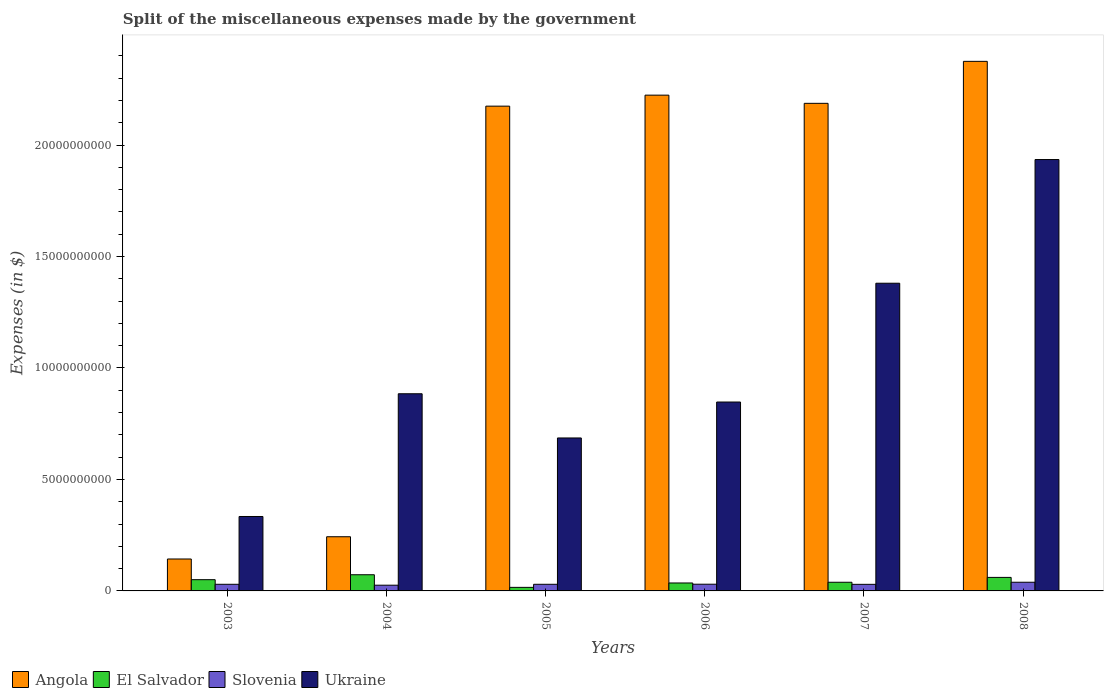How many different coloured bars are there?
Your answer should be very brief. 4. Are the number of bars per tick equal to the number of legend labels?
Offer a very short reply. Yes. How many bars are there on the 2nd tick from the left?
Make the answer very short. 4. How many bars are there on the 2nd tick from the right?
Offer a terse response. 4. What is the miscellaneous expenses made by the government in Angola in 2007?
Make the answer very short. 2.19e+1. Across all years, what is the maximum miscellaneous expenses made by the government in Ukraine?
Offer a very short reply. 1.93e+1. Across all years, what is the minimum miscellaneous expenses made by the government in Angola?
Your answer should be compact. 1.43e+09. In which year was the miscellaneous expenses made by the government in Angola minimum?
Ensure brevity in your answer.  2003. What is the total miscellaneous expenses made by the government in Slovenia in the graph?
Your answer should be compact. 1.84e+09. What is the difference between the miscellaneous expenses made by the government in Slovenia in 2003 and that in 2006?
Offer a very short reply. -2.95e+06. What is the difference between the miscellaneous expenses made by the government in Ukraine in 2006 and the miscellaneous expenses made by the government in Slovenia in 2004?
Provide a short and direct response. 8.22e+09. What is the average miscellaneous expenses made by the government in Ukraine per year?
Your response must be concise. 1.01e+1. In the year 2003, what is the difference between the miscellaneous expenses made by the government in Slovenia and miscellaneous expenses made by the government in El Salvador?
Offer a very short reply. -2.06e+08. In how many years, is the miscellaneous expenses made by the government in Ukraine greater than 17000000000 $?
Provide a short and direct response. 1. What is the ratio of the miscellaneous expenses made by the government in Ukraine in 2003 to that in 2007?
Offer a terse response. 0.24. What is the difference between the highest and the second highest miscellaneous expenses made by the government in Slovenia?
Your answer should be very brief. 8.84e+07. What is the difference between the highest and the lowest miscellaneous expenses made by the government in Ukraine?
Make the answer very short. 1.60e+1. What does the 3rd bar from the left in 2004 represents?
Your answer should be very brief. Slovenia. What does the 1st bar from the right in 2003 represents?
Offer a terse response. Ukraine. Are all the bars in the graph horizontal?
Offer a terse response. No. Does the graph contain grids?
Keep it short and to the point. No. Where does the legend appear in the graph?
Your answer should be compact. Bottom left. How many legend labels are there?
Provide a short and direct response. 4. How are the legend labels stacked?
Your answer should be very brief. Horizontal. What is the title of the graph?
Ensure brevity in your answer.  Split of the miscellaneous expenses made by the government. Does "Kosovo" appear as one of the legend labels in the graph?
Your answer should be compact. No. What is the label or title of the Y-axis?
Keep it short and to the point. Expenses (in $). What is the Expenses (in $) in Angola in 2003?
Provide a succinct answer. 1.43e+09. What is the Expenses (in $) in El Salvador in 2003?
Offer a terse response. 5.04e+08. What is the Expenses (in $) in Slovenia in 2003?
Provide a short and direct response. 2.98e+08. What is the Expenses (in $) in Ukraine in 2003?
Your response must be concise. 3.34e+09. What is the Expenses (in $) of Angola in 2004?
Offer a terse response. 2.43e+09. What is the Expenses (in $) of El Salvador in 2004?
Ensure brevity in your answer.  7.26e+08. What is the Expenses (in $) in Slovenia in 2004?
Your answer should be very brief. 2.57e+08. What is the Expenses (in $) of Ukraine in 2004?
Give a very brief answer. 8.84e+09. What is the Expenses (in $) in Angola in 2005?
Give a very brief answer. 2.17e+1. What is the Expenses (in $) in El Salvador in 2005?
Give a very brief answer. 1.60e+08. What is the Expenses (in $) of Slovenia in 2005?
Make the answer very short. 2.97e+08. What is the Expenses (in $) in Ukraine in 2005?
Keep it short and to the point. 6.86e+09. What is the Expenses (in $) in Angola in 2006?
Keep it short and to the point. 2.22e+1. What is the Expenses (in $) of El Salvador in 2006?
Give a very brief answer. 3.57e+08. What is the Expenses (in $) in Slovenia in 2006?
Provide a succinct answer. 3.01e+08. What is the Expenses (in $) in Ukraine in 2006?
Offer a very short reply. 8.47e+09. What is the Expenses (in $) of Angola in 2007?
Offer a terse response. 2.19e+1. What is the Expenses (in $) in El Salvador in 2007?
Provide a short and direct response. 3.88e+08. What is the Expenses (in $) of Slovenia in 2007?
Offer a terse response. 2.95e+08. What is the Expenses (in $) in Ukraine in 2007?
Provide a succinct answer. 1.38e+1. What is the Expenses (in $) of Angola in 2008?
Make the answer very short. 2.38e+1. What is the Expenses (in $) in El Salvador in 2008?
Give a very brief answer. 6.06e+08. What is the Expenses (in $) of Slovenia in 2008?
Provide a short and direct response. 3.89e+08. What is the Expenses (in $) in Ukraine in 2008?
Your answer should be very brief. 1.93e+1. Across all years, what is the maximum Expenses (in $) in Angola?
Make the answer very short. 2.38e+1. Across all years, what is the maximum Expenses (in $) of El Salvador?
Your response must be concise. 7.26e+08. Across all years, what is the maximum Expenses (in $) in Slovenia?
Your response must be concise. 3.89e+08. Across all years, what is the maximum Expenses (in $) of Ukraine?
Keep it short and to the point. 1.93e+1. Across all years, what is the minimum Expenses (in $) in Angola?
Make the answer very short. 1.43e+09. Across all years, what is the minimum Expenses (in $) of El Salvador?
Give a very brief answer. 1.60e+08. Across all years, what is the minimum Expenses (in $) in Slovenia?
Make the answer very short. 2.57e+08. Across all years, what is the minimum Expenses (in $) in Ukraine?
Your response must be concise. 3.34e+09. What is the total Expenses (in $) in Angola in the graph?
Your answer should be compact. 9.35e+1. What is the total Expenses (in $) in El Salvador in the graph?
Ensure brevity in your answer.  2.74e+09. What is the total Expenses (in $) in Slovenia in the graph?
Ensure brevity in your answer.  1.84e+09. What is the total Expenses (in $) of Ukraine in the graph?
Your response must be concise. 6.07e+1. What is the difference between the Expenses (in $) of Angola in 2003 and that in 2004?
Provide a short and direct response. -9.98e+08. What is the difference between the Expenses (in $) in El Salvador in 2003 and that in 2004?
Provide a short and direct response. -2.22e+08. What is the difference between the Expenses (in $) of Slovenia in 2003 and that in 2004?
Give a very brief answer. 4.09e+07. What is the difference between the Expenses (in $) of Ukraine in 2003 and that in 2004?
Make the answer very short. -5.51e+09. What is the difference between the Expenses (in $) in Angola in 2003 and that in 2005?
Offer a terse response. -2.03e+1. What is the difference between the Expenses (in $) in El Salvador in 2003 and that in 2005?
Offer a very short reply. 3.45e+08. What is the difference between the Expenses (in $) of Slovenia in 2003 and that in 2005?
Keep it short and to the point. 6.05e+05. What is the difference between the Expenses (in $) in Ukraine in 2003 and that in 2005?
Your answer should be very brief. -3.52e+09. What is the difference between the Expenses (in $) in Angola in 2003 and that in 2006?
Your response must be concise. -2.08e+1. What is the difference between the Expenses (in $) in El Salvador in 2003 and that in 2006?
Your response must be concise. 1.48e+08. What is the difference between the Expenses (in $) in Slovenia in 2003 and that in 2006?
Provide a short and direct response. -2.95e+06. What is the difference between the Expenses (in $) in Ukraine in 2003 and that in 2006?
Provide a short and direct response. -5.13e+09. What is the difference between the Expenses (in $) in Angola in 2003 and that in 2007?
Provide a succinct answer. -2.04e+1. What is the difference between the Expenses (in $) of El Salvador in 2003 and that in 2007?
Your answer should be very brief. 1.16e+08. What is the difference between the Expenses (in $) in Slovenia in 2003 and that in 2007?
Your answer should be very brief. 2.34e+06. What is the difference between the Expenses (in $) of Ukraine in 2003 and that in 2007?
Keep it short and to the point. -1.05e+1. What is the difference between the Expenses (in $) of Angola in 2003 and that in 2008?
Give a very brief answer. -2.23e+1. What is the difference between the Expenses (in $) of El Salvador in 2003 and that in 2008?
Provide a short and direct response. -1.02e+08. What is the difference between the Expenses (in $) in Slovenia in 2003 and that in 2008?
Keep it short and to the point. -9.13e+07. What is the difference between the Expenses (in $) in Ukraine in 2003 and that in 2008?
Your response must be concise. -1.60e+1. What is the difference between the Expenses (in $) in Angola in 2004 and that in 2005?
Your answer should be very brief. -1.93e+1. What is the difference between the Expenses (in $) in El Salvador in 2004 and that in 2005?
Keep it short and to the point. 5.66e+08. What is the difference between the Expenses (in $) of Slovenia in 2004 and that in 2005?
Give a very brief answer. -4.03e+07. What is the difference between the Expenses (in $) in Ukraine in 2004 and that in 2005?
Give a very brief answer. 1.98e+09. What is the difference between the Expenses (in $) of Angola in 2004 and that in 2006?
Your answer should be compact. -1.98e+1. What is the difference between the Expenses (in $) of El Salvador in 2004 and that in 2006?
Provide a succinct answer. 3.69e+08. What is the difference between the Expenses (in $) in Slovenia in 2004 and that in 2006?
Your response must be concise. -4.38e+07. What is the difference between the Expenses (in $) of Ukraine in 2004 and that in 2006?
Your answer should be compact. 3.71e+08. What is the difference between the Expenses (in $) of Angola in 2004 and that in 2007?
Provide a succinct answer. -1.94e+1. What is the difference between the Expenses (in $) in El Salvador in 2004 and that in 2007?
Give a very brief answer. 3.37e+08. What is the difference between the Expenses (in $) of Slovenia in 2004 and that in 2007?
Offer a very short reply. -3.85e+07. What is the difference between the Expenses (in $) in Ukraine in 2004 and that in 2007?
Your response must be concise. -4.96e+09. What is the difference between the Expenses (in $) in Angola in 2004 and that in 2008?
Provide a succinct answer. -2.13e+1. What is the difference between the Expenses (in $) of El Salvador in 2004 and that in 2008?
Ensure brevity in your answer.  1.19e+08. What is the difference between the Expenses (in $) in Slovenia in 2004 and that in 2008?
Offer a terse response. -1.32e+08. What is the difference between the Expenses (in $) in Ukraine in 2004 and that in 2008?
Ensure brevity in your answer.  -1.05e+1. What is the difference between the Expenses (in $) of Angola in 2005 and that in 2006?
Your response must be concise. -4.93e+08. What is the difference between the Expenses (in $) in El Salvador in 2005 and that in 2006?
Provide a succinct answer. -1.97e+08. What is the difference between the Expenses (in $) of Slovenia in 2005 and that in 2006?
Keep it short and to the point. -3.55e+06. What is the difference between the Expenses (in $) in Ukraine in 2005 and that in 2006?
Offer a very short reply. -1.61e+09. What is the difference between the Expenses (in $) in Angola in 2005 and that in 2007?
Your answer should be very brief. -1.26e+08. What is the difference between the Expenses (in $) in El Salvador in 2005 and that in 2007?
Provide a succinct answer. -2.29e+08. What is the difference between the Expenses (in $) in Slovenia in 2005 and that in 2007?
Keep it short and to the point. 1.73e+06. What is the difference between the Expenses (in $) in Ukraine in 2005 and that in 2007?
Your response must be concise. -6.94e+09. What is the difference between the Expenses (in $) of Angola in 2005 and that in 2008?
Keep it short and to the point. -2.01e+09. What is the difference between the Expenses (in $) in El Salvador in 2005 and that in 2008?
Keep it short and to the point. -4.47e+08. What is the difference between the Expenses (in $) of Slovenia in 2005 and that in 2008?
Make the answer very short. -9.19e+07. What is the difference between the Expenses (in $) in Ukraine in 2005 and that in 2008?
Give a very brief answer. -1.25e+1. What is the difference between the Expenses (in $) of Angola in 2006 and that in 2007?
Make the answer very short. 3.67e+08. What is the difference between the Expenses (in $) of El Salvador in 2006 and that in 2007?
Provide a succinct answer. -3.19e+07. What is the difference between the Expenses (in $) in Slovenia in 2006 and that in 2007?
Ensure brevity in your answer.  5.28e+06. What is the difference between the Expenses (in $) of Ukraine in 2006 and that in 2007?
Your answer should be compact. -5.33e+09. What is the difference between the Expenses (in $) in Angola in 2006 and that in 2008?
Offer a terse response. -1.52e+09. What is the difference between the Expenses (in $) of El Salvador in 2006 and that in 2008?
Give a very brief answer. -2.50e+08. What is the difference between the Expenses (in $) in Slovenia in 2006 and that in 2008?
Your answer should be compact. -8.84e+07. What is the difference between the Expenses (in $) in Ukraine in 2006 and that in 2008?
Offer a terse response. -1.09e+1. What is the difference between the Expenses (in $) in Angola in 2007 and that in 2008?
Your response must be concise. -1.88e+09. What is the difference between the Expenses (in $) of El Salvador in 2007 and that in 2008?
Provide a short and direct response. -2.18e+08. What is the difference between the Expenses (in $) of Slovenia in 2007 and that in 2008?
Your response must be concise. -9.37e+07. What is the difference between the Expenses (in $) in Ukraine in 2007 and that in 2008?
Provide a succinct answer. -5.55e+09. What is the difference between the Expenses (in $) of Angola in 2003 and the Expenses (in $) of El Salvador in 2004?
Your response must be concise. 7.06e+08. What is the difference between the Expenses (in $) in Angola in 2003 and the Expenses (in $) in Slovenia in 2004?
Your answer should be compact. 1.18e+09. What is the difference between the Expenses (in $) of Angola in 2003 and the Expenses (in $) of Ukraine in 2004?
Give a very brief answer. -7.41e+09. What is the difference between the Expenses (in $) in El Salvador in 2003 and the Expenses (in $) in Slovenia in 2004?
Make the answer very short. 2.47e+08. What is the difference between the Expenses (in $) in El Salvador in 2003 and the Expenses (in $) in Ukraine in 2004?
Provide a short and direct response. -8.34e+09. What is the difference between the Expenses (in $) in Slovenia in 2003 and the Expenses (in $) in Ukraine in 2004?
Your response must be concise. -8.55e+09. What is the difference between the Expenses (in $) in Angola in 2003 and the Expenses (in $) in El Salvador in 2005?
Ensure brevity in your answer.  1.27e+09. What is the difference between the Expenses (in $) in Angola in 2003 and the Expenses (in $) in Slovenia in 2005?
Your answer should be compact. 1.13e+09. What is the difference between the Expenses (in $) in Angola in 2003 and the Expenses (in $) in Ukraine in 2005?
Provide a short and direct response. -5.43e+09. What is the difference between the Expenses (in $) of El Salvador in 2003 and the Expenses (in $) of Slovenia in 2005?
Your answer should be very brief. 2.07e+08. What is the difference between the Expenses (in $) of El Salvador in 2003 and the Expenses (in $) of Ukraine in 2005?
Provide a succinct answer. -6.36e+09. What is the difference between the Expenses (in $) of Slovenia in 2003 and the Expenses (in $) of Ukraine in 2005?
Give a very brief answer. -6.56e+09. What is the difference between the Expenses (in $) in Angola in 2003 and the Expenses (in $) in El Salvador in 2006?
Offer a very short reply. 1.08e+09. What is the difference between the Expenses (in $) in Angola in 2003 and the Expenses (in $) in Slovenia in 2006?
Provide a short and direct response. 1.13e+09. What is the difference between the Expenses (in $) in Angola in 2003 and the Expenses (in $) in Ukraine in 2006?
Give a very brief answer. -7.04e+09. What is the difference between the Expenses (in $) in El Salvador in 2003 and the Expenses (in $) in Slovenia in 2006?
Make the answer very short. 2.03e+08. What is the difference between the Expenses (in $) of El Salvador in 2003 and the Expenses (in $) of Ukraine in 2006?
Keep it short and to the point. -7.97e+09. What is the difference between the Expenses (in $) in Slovenia in 2003 and the Expenses (in $) in Ukraine in 2006?
Offer a very short reply. -8.17e+09. What is the difference between the Expenses (in $) in Angola in 2003 and the Expenses (in $) in El Salvador in 2007?
Give a very brief answer. 1.04e+09. What is the difference between the Expenses (in $) in Angola in 2003 and the Expenses (in $) in Slovenia in 2007?
Your answer should be compact. 1.14e+09. What is the difference between the Expenses (in $) in Angola in 2003 and the Expenses (in $) in Ukraine in 2007?
Your answer should be compact. -1.24e+1. What is the difference between the Expenses (in $) of El Salvador in 2003 and the Expenses (in $) of Slovenia in 2007?
Give a very brief answer. 2.09e+08. What is the difference between the Expenses (in $) in El Salvador in 2003 and the Expenses (in $) in Ukraine in 2007?
Keep it short and to the point. -1.33e+1. What is the difference between the Expenses (in $) in Slovenia in 2003 and the Expenses (in $) in Ukraine in 2007?
Make the answer very short. -1.35e+1. What is the difference between the Expenses (in $) of Angola in 2003 and the Expenses (in $) of El Salvador in 2008?
Make the answer very short. 8.26e+08. What is the difference between the Expenses (in $) of Angola in 2003 and the Expenses (in $) of Slovenia in 2008?
Provide a short and direct response. 1.04e+09. What is the difference between the Expenses (in $) in Angola in 2003 and the Expenses (in $) in Ukraine in 2008?
Offer a terse response. -1.79e+1. What is the difference between the Expenses (in $) of El Salvador in 2003 and the Expenses (in $) of Slovenia in 2008?
Provide a succinct answer. 1.15e+08. What is the difference between the Expenses (in $) in El Salvador in 2003 and the Expenses (in $) in Ukraine in 2008?
Your answer should be very brief. -1.88e+1. What is the difference between the Expenses (in $) of Slovenia in 2003 and the Expenses (in $) of Ukraine in 2008?
Your response must be concise. -1.91e+1. What is the difference between the Expenses (in $) of Angola in 2004 and the Expenses (in $) of El Salvador in 2005?
Provide a succinct answer. 2.27e+09. What is the difference between the Expenses (in $) in Angola in 2004 and the Expenses (in $) in Slovenia in 2005?
Give a very brief answer. 2.13e+09. What is the difference between the Expenses (in $) of Angola in 2004 and the Expenses (in $) of Ukraine in 2005?
Provide a succinct answer. -4.43e+09. What is the difference between the Expenses (in $) in El Salvador in 2004 and the Expenses (in $) in Slovenia in 2005?
Offer a terse response. 4.28e+08. What is the difference between the Expenses (in $) of El Salvador in 2004 and the Expenses (in $) of Ukraine in 2005?
Offer a very short reply. -6.14e+09. What is the difference between the Expenses (in $) of Slovenia in 2004 and the Expenses (in $) of Ukraine in 2005?
Provide a succinct answer. -6.60e+09. What is the difference between the Expenses (in $) in Angola in 2004 and the Expenses (in $) in El Salvador in 2006?
Give a very brief answer. 2.07e+09. What is the difference between the Expenses (in $) in Angola in 2004 and the Expenses (in $) in Slovenia in 2006?
Your answer should be very brief. 2.13e+09. What is the difference between the Expenses (in $) of Angola in 2004 and the Expenses (in $) of Ukraine in 2006?
Offer a terse response. -6.04e+09. What is the difference between the Expenses (in $) of El Salvador in 2004 and the Expenses (in $) of Slovenia in 2006?
Give a very brief answer. 4.25e+08. What is the difference between the Expenses (in $) in El Salvador in 2004 and the Expenses (in $) in Ukraine in 2006?
Your answer should be compact. -7.75e+09. What is the difference between the Expenses (in $) of Slovenia in 2004 and the Expenses (in $) of Ukraine in 2006?
Your response must be concise. -8.22e+09. What is the difference between the Expenses (in $) in Angola in 2004 and the Expenses (in $) in El Salvador in 2007?
Provide a short and direct response. 2.04e+09. What is the difference between the Expenses (in $) of Angola in 2004 and the Expenses (in $) of Slovenia in 2007?
Ensure brevity in your answer.  2.13e+09. What is the difference between the Expenses (in $) in Angola in 2004 and the Expenses (in $) in Ukraine in 2007?
Your response must be concise. -1.14e+1. What is the difference between the Expenses (in $) in El Salvador in 2004 and the Expenses (in $) in Slovenia in 2007?
Your answer should be very brief. 4.30e+08. What is the difference between the Expenses (in $) in El Salvador in 2004 and the Expenses (in $) in Ukraine in 2007?
Your response must be concise. -1.31e+1. What is the difference between the Expenses (in $) in Slovenia in 2004 and the Expenses (in $) in Ukraine in 2007?
Your answer should be very brief. -1.35e+1. What is the difference between the Expenses (in $) of Angola in 2004 and the Expenses (in $) of El Salvador in 2008?
Give a very brief answer. 1.82e+09. What is the difference between the Expenses (in $) in Angola in 2004 and the Expenses (in $) in Slovenia in 2008?
Your answer should be compact. 2.04e+09. What is the difference between the Expenses (in $) in Angola in 2004 and the Expenses (in $) in Ukraine in 2008?
Your answer should be compact. -1.69e+1. What is the difference between the Expenses (in $) in El Salvador in 2004 and the Expenses (in $) in Slovenia in 2008?
Give a very brief answer. 3.37e+08. What is the difference between the Expenses (in $) in El Salvador in 2004 and the Expenses (in $) in Ukraine in 2008?
Give a very brief answer. -1.86e+1. What is the difference between the Expenses (in $) in Slovenia in 2004 and the Expenses (in $) in Ukraine in 2008?
Provide a succinct answer. -1.91e+1. What is the difference between the Expenses (in $) in Angola in 2005 and the Expenses (in $) in El Salvador in 2006?
Your answer should be compact. 2.14e+1. What is the difference between the Expenses (in $) of Angola in 2005 and the Expenses (in $) of Slovenia in 2006?
Your answer should be compact. 2.14e+1. What is the difference between the Expenses (in $) of Angola in 2005 and the Expenses (in $) of Ukraine in 2006?
Keep it short and to the point. 1.33e+1. What is the difference between the Expenses (in $) of El Salvador in 2005 and the Expenses (in $) of Slovenia in 2006?
Keep it short and to the point. -1.41e+08. What is the difference between the Expenses (in $) in El Salvador in 2005 and the Expenses (in $) in Ukraine in 2006?
Keep it short and to the point. -8.31e+09. What is the difference between the Expenses (in $) of Slovenia in 2005 and the Expenses (in $) of Ukraine in 2006?
Offer a very short reply. -8.18e+09. What is the difference between the Expenses (in $) in Angola in 2005 and the Expenses (in $) in El Salvador in 2007?
Your answer should be very brief. 2.14e+1. What is the difference between the Expenses (in $) of Angola in 2005 and the Expenses (in $) of Slovenia in 2007?
Keep it short and to the point. 2.14e+1. What is the difference between the Expenses (in $) of Angola in 2005 and the Expenses (in $) of Ukraine in 2007?
Provide a short and direct response. 7.94e+09. What is the difference between the Expenses (in $) of El Salvador in 2005 and the Expenses (in $) of Slovenia in 2007?
Provide a short and direct response. -1.36e+08. What is the difference between the Expenses (in $) of El Salvador in 2005 and the Expenses (in $) of Ukraine in 2007?
Make the answer very short. -1.36e+1. What is the difference between the Expenses (in $) in Slovenia in 2005 and the Expenses (in $) in Ukraine in 2007?
Make the answer very short. -1.35e+1. What is the difference between the Expenses (in $) in Angola in 2005 and the Expenses (in $) in El Salvador in 2008?
Ensure brevity in your answer.  2.11e+1. What is the difference between the Expenses (in $) in Angola in 2005 and the Expenses (in $) in Slovenia in 2008?
Your response must be concise. 2.14e+1. What is the difference between the Expenses (in $) in Angola in 2005 and the Expenses (in $) in Ukraine in 2008?
Give a very brief answer. 2.39e+09. What is the difference between the Expenses (in $) in El Salvador in 2005 and the Expenses (in $) in Slovenia in 2008?
Make the answer very short. -2.30e+08. What is the difference between the Expenses (in $) in El Salvador in 2005 and the Expenses (in $) in Ukraine in 2008?
Provide a short and direct response. -1.92e+1. What is the difference between the Expenses (in $) in Slovenia in 2005 and the Expenses (in $) in Ukraine in 2008?
Give a very brief answer. -1.91e+1. What is the difference between the Expenses (in $) in Angola in 2006 and the Expenses (in $) in El Salvador in 2007?
Your answer should be very brief. 2.18e+1. What is the difference between the Expenses (in $) of Angola in 2006 and the Expenses (in $) of Slovenia in 2007?
Provide a succinct answer. 2.19e+1. What is the difference between the Expenses (in $) of Angola in 2006 and the Expenses (in $) of Ukraine in 2007?
Your answer should be compact. 8.44e+09. What is the difference between the Expenses (in $) in El Salvador in 2006 and the Expenses (in $) in Slovenia in 2007?
Offer a terse response. 6.11e+07. What is the difference between the Expenses (in $) of El Salvador in 2006 and the Expenses (in $) of Ukraine in 2007?
Provide a short and direct response. -1.34e+1. What is the difference between the Expenses (in $) of Slovenia in 2006 and the Expenses (in $) of Ukraine in 2007?
Ensure brevity in your answer.  -1.35e+1. What is the difference between the Expenses (in $) of Angola in 2006 and the Expenses (in $) of El Salvador in 2008?
Ensure brevity in your answer.  2.16e+1. What is the difference between the Expenses (in $) in Angola in 2006 and the Expenses (in $) in Slovenia in 2008?
Your response must be concise. 2.18e+1. What is the difference between the Expenses (in $) in Angola in 2006 and the Expenses (in $) in Ukraine in 2008?
Make the answer very short. 2.89e+09. What is the difference between the Expenses (in $) of El Salvador in 2006 and the Expenses (in $) of Slovenia in 2008?
Offer a very short reply. -3.25e+07. What is the difference between the Expenses (in $) of El Salvador in 2006 and the Expenses (in $) of Ukraine in 2008?
Your answer should be compact. -1.90e+1. What is the difference between the Expenses (in $) in Slovenia in 2006 and the Expenses (in $) in Ukraine in 2008?
Your answer should be compact. -1.90e+1. What is the difference between the Expenses (in $) of Angola in 2007 and the Expenses (in $) of El Salvador in 2008?
Offer a very short reply. 2.13e+1. What is the difference between the Expenses (in $) of Angola in 2007 and the Expenses (in $) of Slovenia in 2008?
Offer a terse response. 2.15e+1. What is the difference between the Expenses (in $) in Angola in 2007 and the Expenses (in $) in Ukraine in 2008?
Offer a terse response. 2.52e+09. What is the difference between the Expenses (in $) in El Salvador in 2007 and the Expenses (in $) in Slovenia in 2008?
Offer a very short reply. -6.24e+05. What is the difference between the Expenses (in $) in El Salvador in 2007 and the Expenses (in $) in Ukraine in 2008?
Provide a succinct answer. -1.90e+1. What is the difference between the Expenses (in $) of Slovenia in 2007 and the Expenses (in $) of Ukraine in 2008?
Keep it short and to the point. -1.91e+1. What is the average Expenses (in $) of Angola per year?
Keep it short and to the point. 1.56e+1. What is the average Expenses (in $) in El Salvador per year?
Provide a short and direct response. 4.57e+08. What is the average Expenses (in $) of Slovenia per year?
Offer a terse response. 3.06e+08. What is the average Expenses (in $) of Ukraine per year?
Offer a very short reply. 1.01e+1. In the year 2003, what is the difference between the Expenses (in $) of Angola and Expenses (in $) of El Salvador?
Your answer should be compact. 9.28e+08. In the year 2003, what is the difference between the Expenses (in $) in Angola and Expenses (in $) in Slovenia?
Ensure brevity in your answer.  1.13e+09. In the year 2003, what is the difference between the Expenses (in $) of Angola and Expenses (in $) of Ukraine?
Offer a terse response. -1.91e+09. In the year 2003, what is the difference between the Expenses (in $) of El Salvador and Expenses (in $) of Slovenia?
Make the answer very short. 2.06e+08. In the year 2003, what is the difference between the Expenses (in $) of El Salvador and Expenses (in $) of Ukraine?
Provide a short and direct response. -2.83e+09. In the year 2003, what is the difference between the Expenses (in $) of Slovenia and Expenses (in $) of Ukraine?
Offer a terse response. -3.04e+09. In the year 2004, what is the difference between the Expenses (in $) in Angola and Expenses (in $) in El Salvador?
Your answer should be very brief. 1.70e+09. In the year 2004, what is the difference between the Expenses (in $) of Angola and Expenses (in $) of Slovenia?
Ensure brevity in your answer.  2.17e+09. In the year 2004, what is the difference between the Expenses (in $) in Angola and Expenses (in $) in Ukraine?
Your answer should be very brief. -6.41e+09. In the year 2004, what is the difference between the Expenses (in $) in El Salvador and Expenses (in $) in Slovenia?
Your answer should be compact. 4.69e+08. In the year 2004, what is the difference between the Expenses (in $) of El Salvador and Expenses (in $) of Ukraine?
Offer a very short reply. -8.12e+09. In the year 2004, what is the difference between the Expenses (in $) of Slovenia and Expenses (in $) of Ukraine?
Your answer should be very brief. -8.59e+09. In the year 2005, what is the difference between the Expenses (in $) in Angola and Expenses (in $) in El Salvador?
Your answer should be compact. 2.16e+1. In the year 2005, what is the difference between the Expenses (in $) in Angola and Expenses (in $) in Slovenia?
Give a very brief answer. 2.14e+1. In the year 2005, what is the difference between the Expenses (in $) of Angola and Expenses (in $) of Ukraine?
Offer a very short reply. 1.49e+1. In the year 2005, what is the difference between the Expenses (in $) in El Salvador and Expenses (in $) in Slovenia?
Offer a very short reply. -1.38e+08. In the year 2005, what is the difference between the Expenses (in $) of El Salvador and Expenses (in $) of Ukraine?
Your answer should be very brief. -6.70e+09. In the year 2005, what is the difference between the Expenses (in $) in Slovenia and Expenses (in $) in Ukraine?
Give a very brief answer. -6.56e+09. In the year 2006, what is the difference between the Expenses (in $) of Angola and Expenses (in $) of El Salvador?
Make the answer very short. 2.19e+1. In the year 2006, what is the difference between the Expenses (in $) in Angola and Expenses (in $) in Slovenia?
Provide a succinct answer. 2.19e+1. In the year 2006, what is the difference between the Expenses (in $) of Angola and Expenses (in $) of Ukraine?
Provide a succinct answer. 1.38e+1. In the year 2006, what is the difference between the Expenses (in $) of El Salvador and Expenses (in $) of Slovenia?
Give a very brief answer. 5.58e+07. In the year 2006, what is the difference between the Expenses (in $) in El Salvador and Expenses (in $) in Ukraine?
Ensure brevity in your answer.  -8.12e+09. In the year 2006, what is the difference between the Expenses (in $) in Slovenia and Expenses (in $) in Ukraine?
Provide a short and direct response. -8.17e+09. In the year 2007, what is the difference between the Expenses (in $) in Angola and Expenses (in $) in El Salvador?
Give a very brief answer. 2.15e+1. In the year 2007, what is the difference between the Expenses (in $) of Angola and Expenses (in $) of Slovenia?
Offer a very short reply. 2.16e+1. In the year 2007, what is the difference between the Expenses (in $) in Angola and Expenses (in $) in Ukraine?
Offer a terse response. 8.07e+09. In the year 2007, what is the difference between the Expenses (in $) of El Salvador and Expenses (in $) of Slovenia?
Ensure brevity in your answer.  9.30e+07. In the year 2007, what is the difference between the Expenses (in $) in El Salvador and Expenses (in $) in Ukraine?
Give a very brief answer. -1.34e+1. In the year 2007, what is the difference between the Expenses (in $) of Slovenia and Expenses (in $) of Ukraine?
Provide a succinct answer. -1.35e+1. In the year 2008, what is the difference between the Expenses (in $) in Angola and Expenses (in $) in El Salvador?
Provide a short and direct response. 2.31e+1. In the year 2008, what is the difference between the Expenses (in $) of Angola and Expenses (in $) of Slovenia?
Offer a terse response. 2.34e+1. In the year 2008, what is the difference between the Expenses (in $) in Angola and Expenses (in $) in Ukraine?
Your answer should be compact. 4.40e+09. In the year 2008, what is the difference between the Expenses (in $) in El Salvador and Expenses (in $) in Slovenia?
Provide a succinct answer. 2.17e+08. In the year 2008, what is the difference between the Expenses (in $) of El Salvador and Expenses (in $) of Ukraine?
Your response must be concise. -1.87e+1. In the year 2008, what is the difference between the Expenses (in $) of Slovenia and Expenses (in $) of Ukraine?
Ensure brevity in your answer.  -1.90e+1. What is the ratio of the Expenses (in $) of Angola in 2003 to that in 2004?
Your response must be concise. 0.59. What is the ratio of the Expenses (in $) of El Salvador in 2003 to that in 2004?
Your answer should be compact. 0.69. What is the ratio of the Expenses (in $) in Slovenia in 2003 to that in 2004?
Give a very brief answer. 1.16. What is the ratio of the Expenses (in $) in Ukraine in 2003 to that in 2004?
Offer a terse response. 0.38. What is the ratio of the Expenses (in $) in Angola in 2003 to that in 2005?
Your answer should be very brief. 0.07. What is the ratio of the Expenses (in $) in El Salvador in 2003 to that in 2005?
Keep it short and to the point. 3.16. What is the ratio of the Expenses (in $) of Ukraine in 2003 to that in 2005?
Ensure brevity in your answer.  0.49. What is the ratio of the Expenses (in $) in Angola in 2003 to that in 2006?
Provide a succinct answer. 0.06. What is the ratio of the Expenses (in $) of El Salvador in 2003 to that in 2006?
Offer a terse response. 1.41. What is the ratio of the Expenses (in $) of Slovenia in 2003 to that in 2006?
Keep it short and to the point. 0.99. What is the ratio of the Expenses (in $) of Ukraine in 2003 to that in 2006?
Your answer should be very brief. 0.39. What is the ratio of the Expenses (in $) of Angola in 2003 to that in 2007?
Give a very brief answer. 0.07. What is the ratio of the Expenses (in $) in El Salvador in 2003 to that in 2007?
Your response must be concise. 1.3. What is the ratio of the Expenses (in $) of Slovenia in 2003 to that in 2007?
Your response must be concise. 1.01. What is the ratio of the Expenses (in $) of Ukraine in 2003 to that in 2007?
Your answer should be compact. 0.24. What is the ratio of the Expenses (in $) in Angola in 2003 to that in 2008?
Your response must be concise. 0.06. What is the ratio of the Expenses (in $) of El Salvador in 2003 to that in 2008?
Keep it short and to the point. 0.83. What is the ratio of the Expenses (in $) in Slovenia in 2003 to that in 2008?
Your answer should be compact. 0.77. What is the ratio of the Expenses (in $) of Ukraine in 2003 to that in 2008?
Keep it short and to the point. 0.17. What is the ratio of the Expenses (in $) in Angola in 2004 to that in 2005?
Your answer should be compact. 0.11. What is the ratio of the Expenses (in $) of El Salvador in 2004 to that in 2005?
Ensure brevity in your answer.  4.55. What is the ratio of the Expenses (in $) of Slovenia in 2004 to that in 2005?
Your answer should be compact. 0.86. What is the ratio of the Expenses (in $) in Ukraine in 2004 to that in 2005?
Your answer should be compact. 1.29. What is the ratio of the Expenses (in $) of Angola in 2004 to that in 2006?
Offer a terse response. 0.11. What is the ratio of the Expenses (in $) of El Salvador in 2004 to that in 2006?
Your response must be concise. 2.04. What is the ratio of the Expenses (in $) in Slovenia in 2004 to that in 2006?
Offer a terse response. 0.85. What is the ratio of the Expenses (in $) of Ukraine in 2004 to that in 2006?
Your answer should be very brief. 1.04. What is the ratio of the Expenses (in $) in Angola in 2004 to that in 2007?
Your response must be concise. 0.11. What is the ratio of the Expenses (in $) in El Salvador in 2004 to that in 2007?
Keep it short and to the point. 1.87. What is the ratio of the Expenses (in $) of Slovenia in 2004 to that in 2007?
Give a very brief answer. 0.87. What is the ratio of the Expenses (in $) of Ukraine in 2004 to that in 2007?
Provide a short and direct response. 0.64. What is the ratio of the Expenses (in $) in Angola in 2004 to that in 2008?
Provide a short and direct response. 0.1. What is the ratio of the Expenses (in $) in El Salvador in 2004 to that in 2008?
Make the answer very short. 1.2. What is the ratio of the Expenses (in $) in Slovenia in 2004 to that in 2008?
Offer a very short reply. 0.66. What is the ratio of the Expenses (in $) of Ukraine in 2004 to that in 2008?
Keep it short and to the point. 0.46. What is the ratio of the Expenses (in $) in Angola in 2005 to that in 2006?
Give a very brief answer. 0.98. What is the ratio of the Expenses (in $) of El Salvador in 2005 to that in 2006?
Ensure brevity in your answer.  0.45. What is the ratio of the Expenses (in $) of Ukraine in 2005 to that in 2006?
Provide a succinct answer. 0.81. What is the ratio of the Expenses (in $) in Angola in 2005 to that in 2007?
Ensure brevity in your answer.  0.99. What is the ratio of the Expenses (in $) of El Salvador in 2005 to that in 2007?
Offer a very short reply. 0.41. What is the ratio of the Expenses (in $) in Slovenia in 2005 to that in 2007?
Offer a very short reply. 1.01. What is the ratio of the Expenses (in $) in Ukraine in 2005 to that in 2007?
Ensure brevity in your answer.  0.5. What is the ratio of the Expenses (in $) in Angola in 2005 to that in 2008?
Keep it short and to the point. 0.92. What is the ratio of the Expenses (in $) in El Salvador in 2005 to that in 2008?
Provide a succinct answer. 0.26. What is the ratio of the Expenses (in $) in Slovenia in 2005 to that in 2008?
Offer a terse response. 0.76. What is the ratio of the Expenses (in $) in Ukraine in 2005 to that in 2008?
Your answer should be very brief. 0.35. What is the ratio of the Expenses (in $) of Angola in 2006 to that in 2007?
Make the answer very short. 1.02. What is the ratio of the Expenses (in $) of El Salvador in 2006 to that in 2007?
Your answer should be very brief. 0.92. What is the ratio of the Expenses (in $) in Slovenia in 2006 to that in 2007?
Your answer should be very brief. 1.02. What is the ratio of the Expenses (in $) of Ukraine in 2006 to that in 2007?
Offer a terse response. 0.61. What is the ratio of the Expenses (in $) of Angola in 2006 to that in 2008?
Keep it short and to the point. 0.94. What is the ratio of the Expenses (in $) in El Salvador in 2006 to that in 2008?
Your answer should be very brief. 0.59. What is the ratio of the Expenses (in $) in Slovenia in 2006 to that in 2008?
Make the answer very short. 0.77. What is the ratio of the Expenses (in $) of Ukraine in 2006 to that in 2008?
Ensure brevity in your answer.  0.44. What is the ratio of the Expenses (in $) of Angola in 2007 to that in 2008?
Your answer should be compact. 0.92. What is the ratio of the Expenses (in $) of El Salvador in 2007 to that in 2008?
Give a very brief answer. 0.64. What is the ratio of the Expenses (in $) of Slovenia in 2007 to that in 2008?
Your answer should be very brief. 0.76. What is the ratio of the Expenses (in $) in Ukraine in 2007 to that in 2008?
Offer a terse response. 0.71. What is the difference between the highest and the second highest Expenses (in $) of Angola?
Your answer should be compact. 1.52e+09. What is the difference between the highest and the second highest Expenses (in $) of El Salvador?
Make the answer very short. 1.19e+08. What is the difference between the highest and the second highest Expenses (in $) in Slovenia?
Your answer should be very brief. 8.84e+07. What is the difference between the highest and the second highest Expenses (in $) of Ukraine?
Offer a terse response. 5.55e+09. What is the difference between the highest and the lowest Expenses (in $) of Angola?
Keep it short and to the point. 2.23e+1. What is the difference between the highest and the lowest Expenses (in $) in El Salvador?
Your response must be concise. 5.66e+08. What is the difference between the highest and the lowest Expenses (in $) in Slovenia?
Your answer should be compact. 1.32e+08. What is the difference between the highest and the lowest Expenses (in $) of Ukraine?
Your answer should be compact. 1.60e+1. 